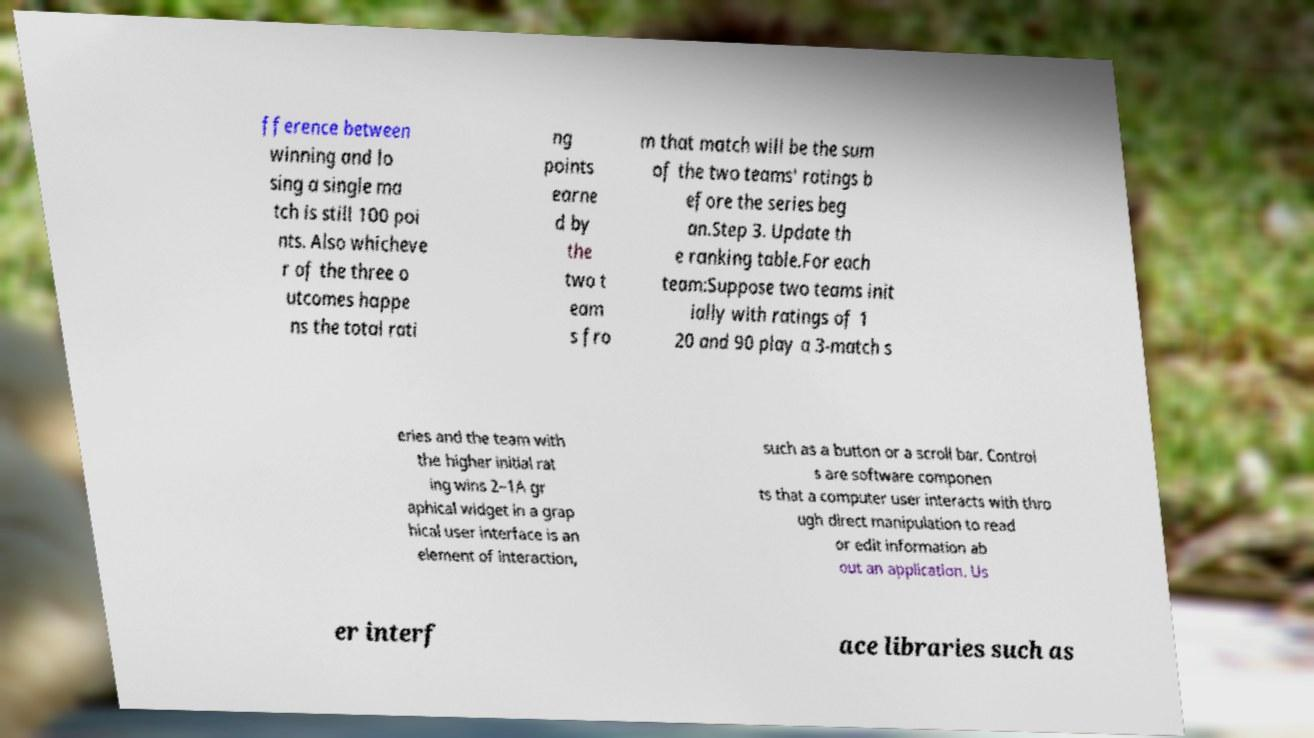What messages or text are displayed in this image? I need them in a readable, typed format. fference between winning and lo sing a single ma tch is still 100 poi nts. Also whicheve r of the three o utcomes happe ns the total rati ng points earne d by the two t eam s fro m that match will be the sum of the two teams' ratings b efore the series beg an.Step 3. Update th e ranking table.For each team:Suppose two teams init ially with ratings of 1 20 and 90 play a 3-match s eries and the team with the higher initial rat ing wins 2–1A gr aphical widget in a grap hical user interface is an element of interaction, such as a button or a scroll bar. Control s are software componen ts that a computer user interacts with thro ugh direct manipulation to read or edit information ab out an application. Us er interf ace libraries such as 